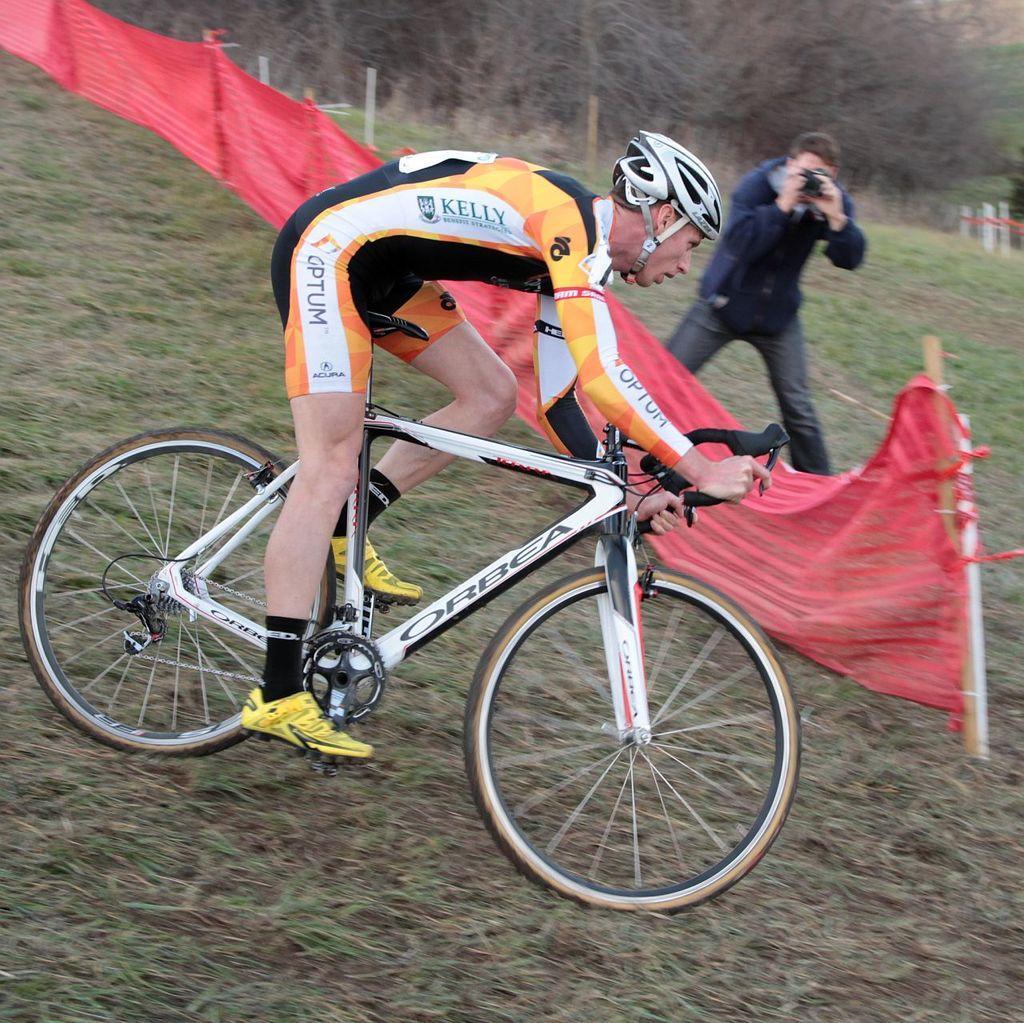In one or two sentences, can you explain what this image depicts? In this image in the center there is one person who is sitting on a cycle and driving, in the background there is another person who is standing and he is holding a camera and clicking pictures and in the center there is a fence. At the bottom there is grass, and in the background there are some trees and poles. 